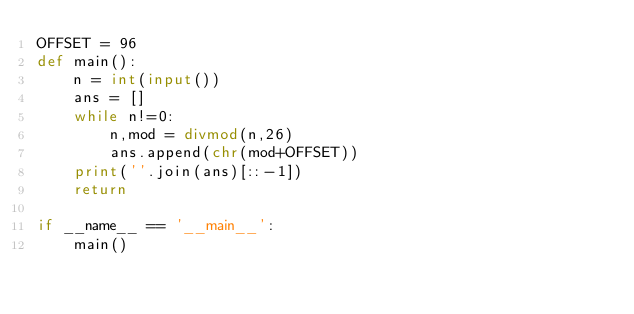Convert code to text. <code><loc_0><loc_0><loc_500><loc_500><_Python_>OFFSET = 96
def main():
    n = int(input())
    ans = []
    while n!=0:
        n,mod = divmod(n,26)
        ans.append(chr(mod+OFFSET))
    print(''.join(ans)[::-1])
    return

if __name__ == '__main__':
    main()</code> 